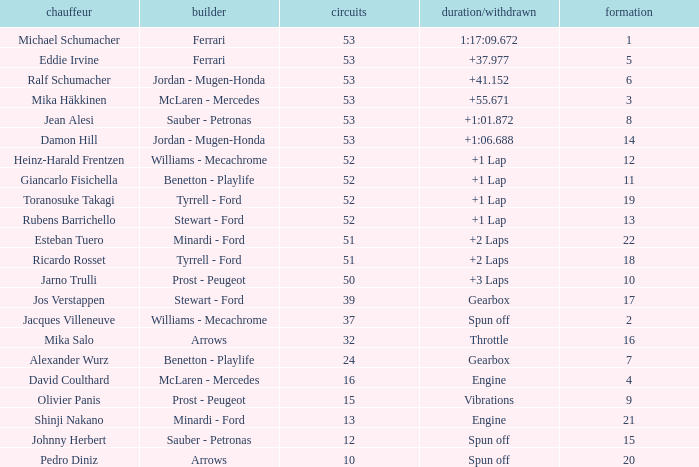What is the high lap total for pedro diniz? 10.0. 